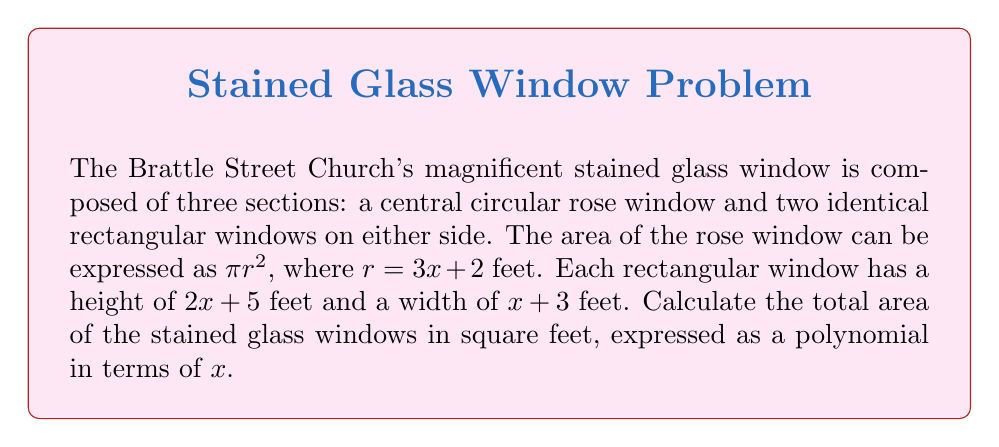Could you help me with this problem? Let's approach this problem step by step:

1) First, let's calculate the area of the rose window:
   Area of circle = $\pi r^2$
   $r = 3x + 2$
   Area of rose window = $\pi(3x + 2)^2$
   
   Expanding this:
   $\pi(3x + 2)^2 = \pi(9x^2 + 12x + 4) = 9\pi x^2 + 12\pi x + 4\pi$

2) Now, let's calculate the area of one rectangular window:
   Area of rectangle = length × width
   $= (2x + 5)(x + 3)$
   $= 2x^2 + 6x + 5x + 15$
   $= 2x^2 + 11x + 15$

3) Since there are two identical rectangular windows, we double this area:
   Area of both rectangular windows = $2(2x^2 + 11x + 15)$
   $= 4x^2 + 22x + 30$

4) The total area is the sum of the rose window and both rectangular windows:
   Total Area = $(9\pi x^2 + 12\pi x + 4\pi) + (4x^2 + 22x + 30)$
   
   Combining like terms:
   $= (9\pi + 4)x^2 + (12\pi + 22)x + (4\pi + 30)$

This is the polynomial expression for the total area in terms of $x$.
Answer: $(9\pi + 4)x^2 + (12\pi + 22)x + (4\pi + 30)$ square feet 